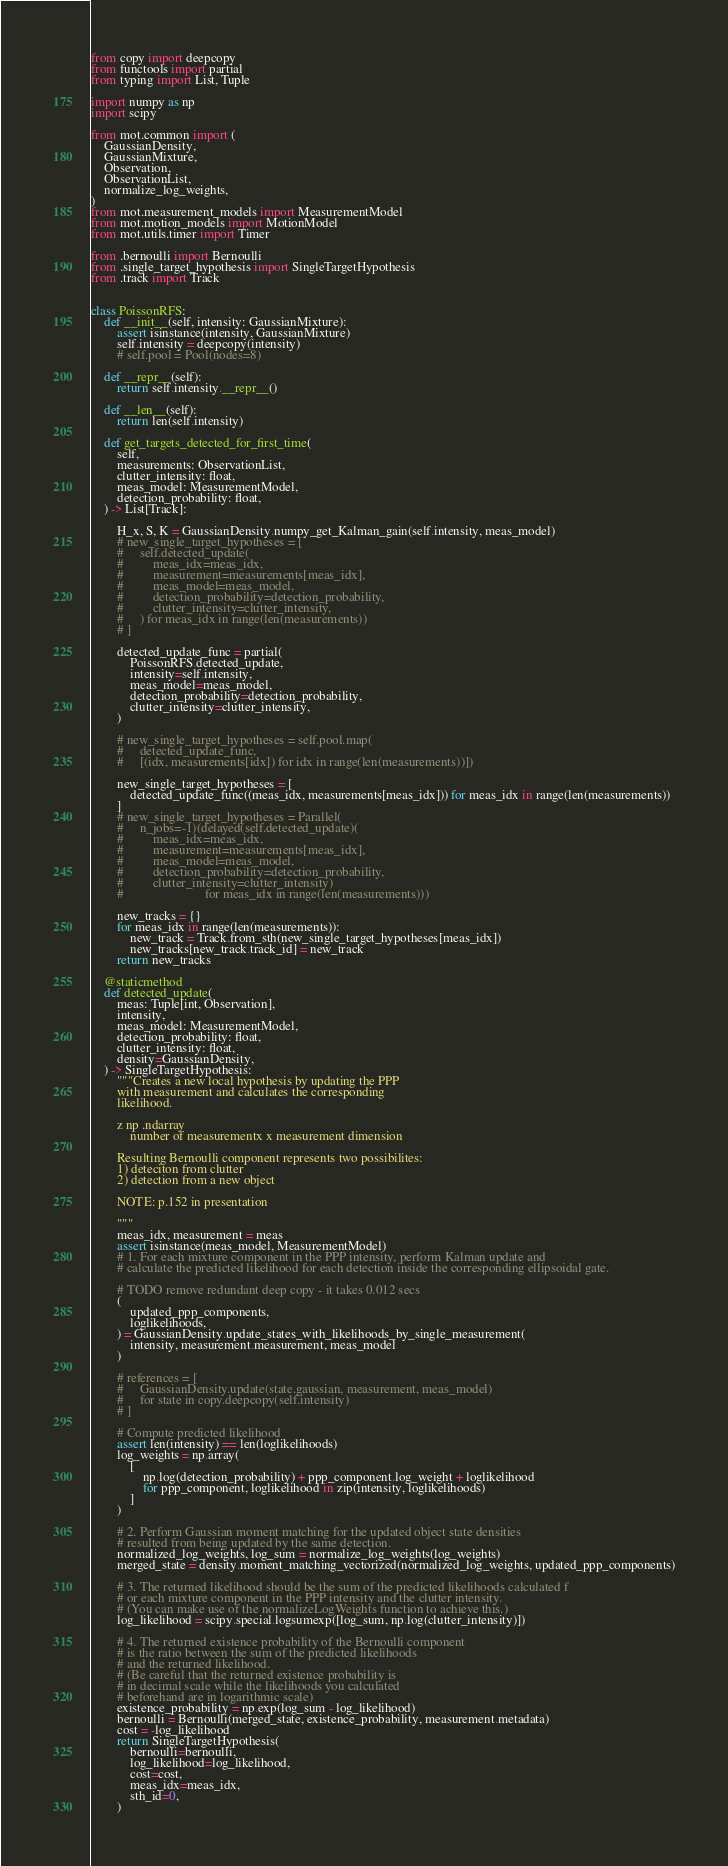<code> <loc_0><loc_0><loc_500><loc_500><_Python_>from copy import deepcopy
from functools import partial
from typing import List, Tuple

import numpy as np
import scipy

from mot.common import (
    GaussianDensity,
    GaussianMixture,
    Observation,
    ObservationList,
    normalize_log_weights,
)
from mot.measurement_models import MeasurementModel
from mot.motion_models import MotionModel
from mot.utils.timer import Timer

from .bernoulli import Bernoulli
from .single_target_hypothesis import SingleTargetHypothesis
from .track import Track


class PoissonRFS:
    def __init__(self, intensity: GaussianMixture):
        assert isinstance(intensity, GaussianMixture)
        self.intensity = deepcopy(intensity)
        # self.pool = Pool(nodes=8)

    def __repr__(self):
        return self.intensity.__repr__()

    def __len__(self):
        return len(self.intensity)

    def get_targets_detected_for_first_time(
        self,
        measurements: ObservationList,
        clutter_intensity: float,
        meas_model: MeasurementModel,
        detection_probability: float,
    ) -> List[Track]:

        H_x, S, K = GaussianDensity.numpy_get_Kalman_gain(self.intensity, meas_model)
        # new_single_target_hypotheses = [
        #     self.detected_update(
        #         meas_idx=meas_idx,
        #         measurement=measurements[meas_idx],
        #         meas_model=meas_model,
        #         detection_probability=detection_probability,
        #         clutter_intensity=clutter_intensity,
        #     ) for meas_idx in range(len(measurements))
        # ]

        detected_update_func = partial(
            PoissonRFS.detected_update,
            intensity=self.intensity,
            meas_model=meas_model,
            detection_probability=detection_probability,
            clutter_intensity=clutter_intensity,
        )

        # new_single_target_hypotheses = self.pool.map(
        #     detected_update_func,
        #     [(idx, measurements[idx]) for idx in range(len(measurements))])

        new_single_target_hypotheses = [
            detected_update_func((meas_idx, measurements[meas_idx])) for meas_idx in range(len(measurements))
        ]
        # new_single_target_hypotheses = Parallel(
        #     n_jobs=-1)(delayed(self.detected_update)(
        #         meas_idx=meas_idx,
        #         measurement=measurements[meas_idx],
        #         meas_model=meas_model,
        #         detection_probability=detection_probability,
        #         clutter_intensity=clutter_intensity)
        #                         for meas_idx in range(len(measurements)))

        new_tracks = {}
        for meas_idx in range(len(measurements)):
            new_track = Track.from_sth(new_single_target_hypotheses[meas_idx])
            new_tracks[new_track.track_id] = new_track
        return new_tracks

    @staticmethod
    def detected_update(
        meas: Tuple[int, Observation],
        intensity,
        meas_model: MeasurementModel,
        detection_probability: float,
        clutter_intensity: float,
        density=GaussianDensity,
    ) -> SingleTargetHypothesis:
        """Creates a new local hypothesis by updating the PPP
        with measurement and calculates the corresponding
        likelihood.

        z np .ndarray
            number of measurementx x measurement dimension

        Resulting Bernoulli component represents two possibilites:
        1) deteciton from clutter
        2) detection from a new object

        NOTE: p.152 in presentation

        """
        meas_idx, measurement = meas
        assert isinstance(meas_model, MeasurementModel)
        # 1. For each mixture component in the PPP intensity, perform Kalman update and
        # calculate the predicted likelihood for each detection inside the corresponding ellipsoidal gate.

        # TODO remove redundant deep copy - it takes 0.012 secs
        (
            updated_ppp_components,
            loglikelihoods,
        ) = GaussianDensity.update_states_with_likelihoods_by_single_measurement(
            intensity, measurement.measurement, meas_model
        )

        # references = [
        #     GaussianDensity.update(state.gaussian, measurement, meas_model)
        #     for state in copy.deepcopy(self.intensity)
        # ]

        # Compute predicted likelihood
        assert len(intensity) == len(loglikelihoods)
        log_weights = np.array(
            [
                np.log(detection_probability) + ppp_component.log_weight + loglikelihood
                for ppp_component, loglikelihood in zip(intensity, loglikelihoods)
            ]
        )

        # 2. Perform Gaussian moment matching for the updated object state densities
        # resulted from being updated by the same detection.
        normalized_log_weights, log_sum = normalize_log_weights(log_weights)
        merged_state = density.moment_matching_vectorized(normalized_log_weights, updated_ppp_components)

        # 3. The returned likelihood should be the sum of the predicted likelihoods calculated f
        # or each mixture component in the PPP intensity and the clutter intensity.
        # (You can make use of the normalizeLogWeights function to achieve this.)
        log_likelihood = scipy.special.logsumexp([log_sum, np.log(clutter_intensity)])

        # 4. The returned existence probability of the Bernoulli component
        # is the ratio between the sum of the predicted likelihoods
        # and the returned likelihood.
        # (Be careful that the returned existence probability is
        # in decimal scale while the likelihoods you calculated
        # beforehand are in logarithmic scale)
        existence_probability = np.exp(log_sum - log_likelihood)
        bernoulli = Bernoulli(merged_state, existence_probability, measurement.metadata)
        cost = -log_likelihood
        return SingleTargetHypothesis(
            bernoulli=bernoulli,
            log_likelihood=log_likelihood,
            cost=cost,
            meas_idx=meas_idx,
            sth_id=0,
        )
</code> 